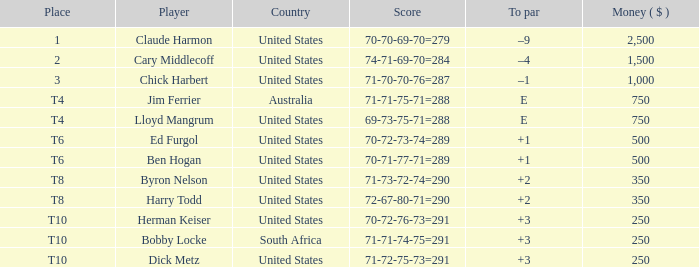What is the to par for the player from the usa with a 72-67-80-71=290 score? 2.0. 